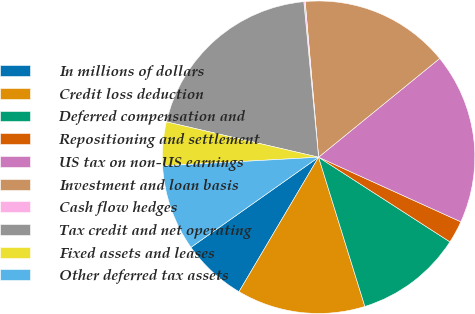Convert chart to OTSL. <chart><loc_0><loc_0><loc_500><loc_500><pie_chart><fcel>In millions of dollars<fcel>Credit loss deduction<fcel>Deferred compensation and<fcel>Repositioning and settlement<fcel>US tax on non-US earnings<fcel>Investment and loan basis<fcel>Cash flow hedges<fcel>Tax credit and net operating<fcel>Fixed assets and leases<fcel>Other deferred tax assets<nl><fcel>6.71%<fcel>13.29%<fcel>11.1%<fcel>2.33%<fcel>17.67%<fcel>15.48%<fcel>0.14%<fcel>19.86%<fcel>4.52%<fcel>8.9%<nl></chart> 